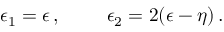Convert formula to latex. <formula><loc_0><loc_0><loc_500><loc_500>\epsilon _ { 1 } = \epsilon \, , \quad e p s i l o n _ { 2 } = 2 ( \epsilon - \eta ) \, .</formula> 